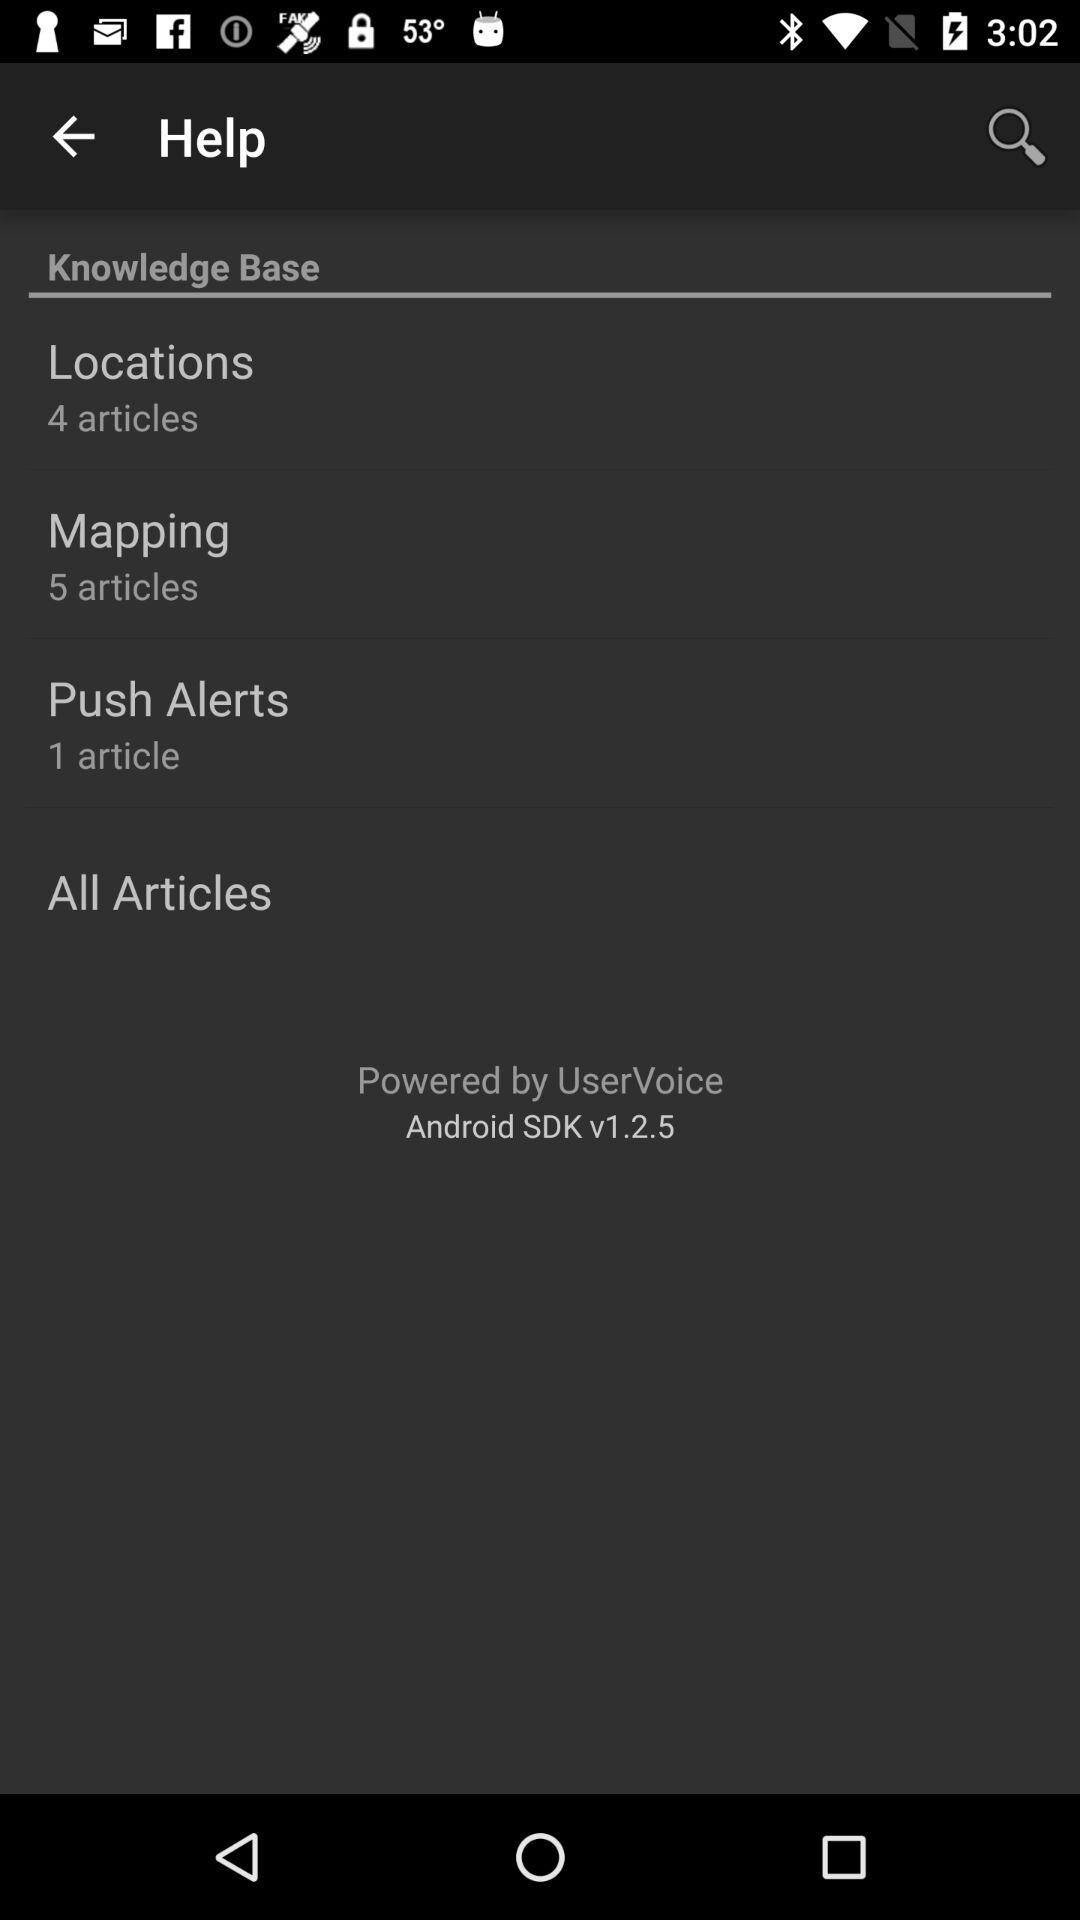How many articles are there in total in the Knowledge Base?
Answer the question using a single word or phrase. 10 